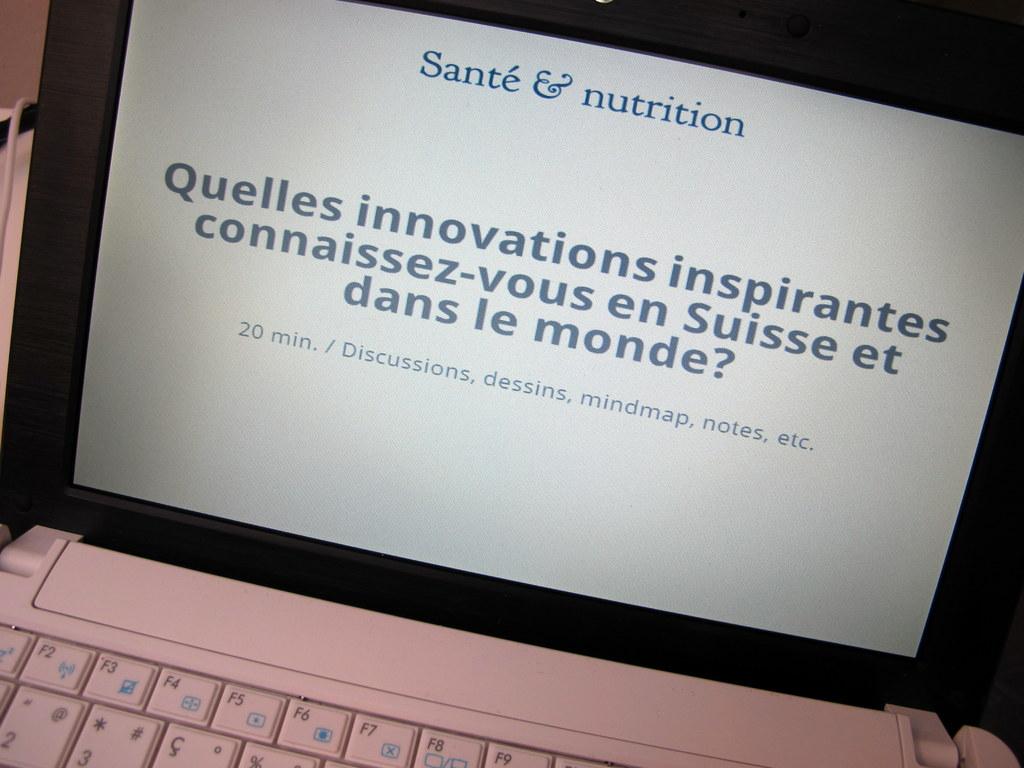What is the title at the top of the screen?
Your answer should be compact. Sante & nutrition. How many minutes?
Provide a short and direct response. 20. 